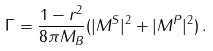<formula> <loc_0><loc_0><loc_500><loc_500>\Gamma = \frac { 1 - r ^ { 2 } } { 8 \pi M _ { B } } ( | M ^ { S } | ^ { 2 } + | M ^ { P } | ^ { 2 } ) \, .</formula> 